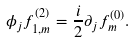<formula> <loc_0><loc_0><loc_500><loc_500>\phi _ { j } f ^ { ( 2 ) } _ { 1 , m } = \frac { i } { 2 } \partial _ { j } f ^ { ( 0 ) } _ { m } .</formula> 